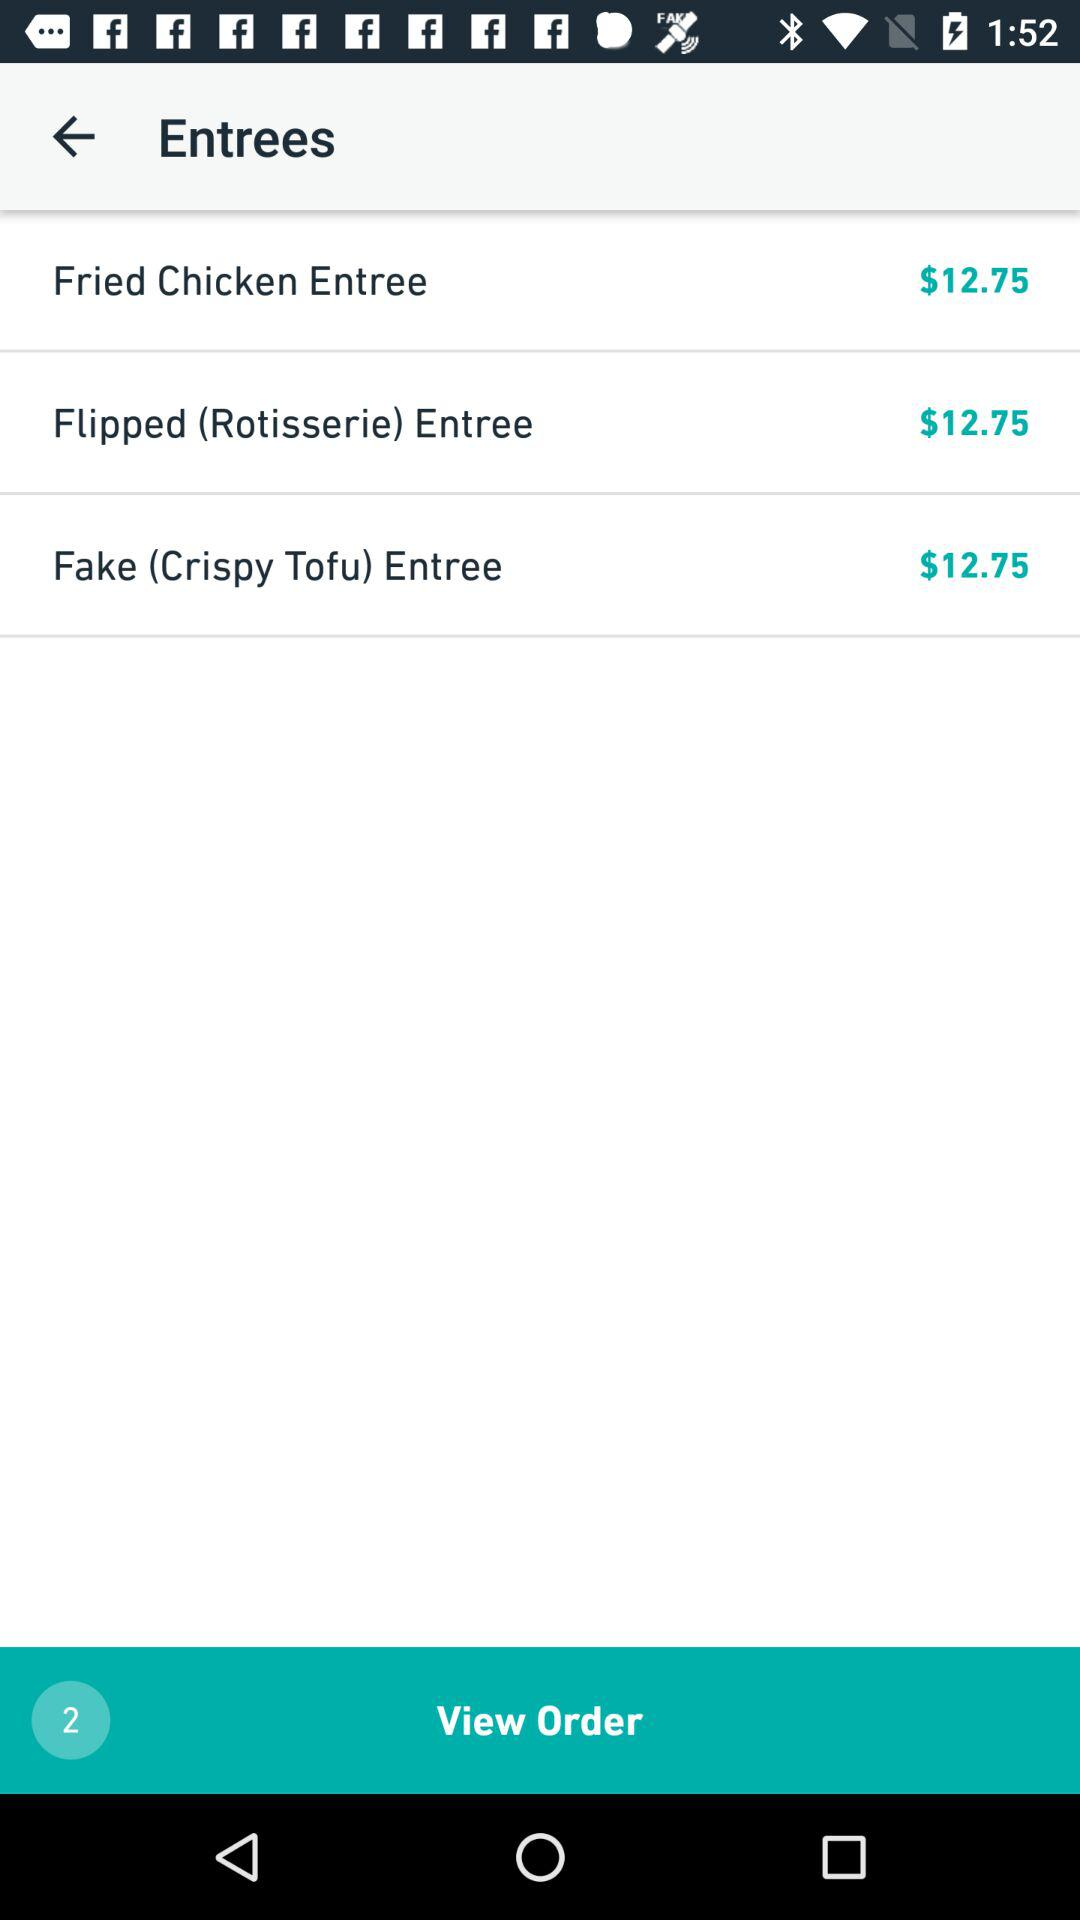How many entrees are in the order?
Answer the question using a single word or phrase. 3 